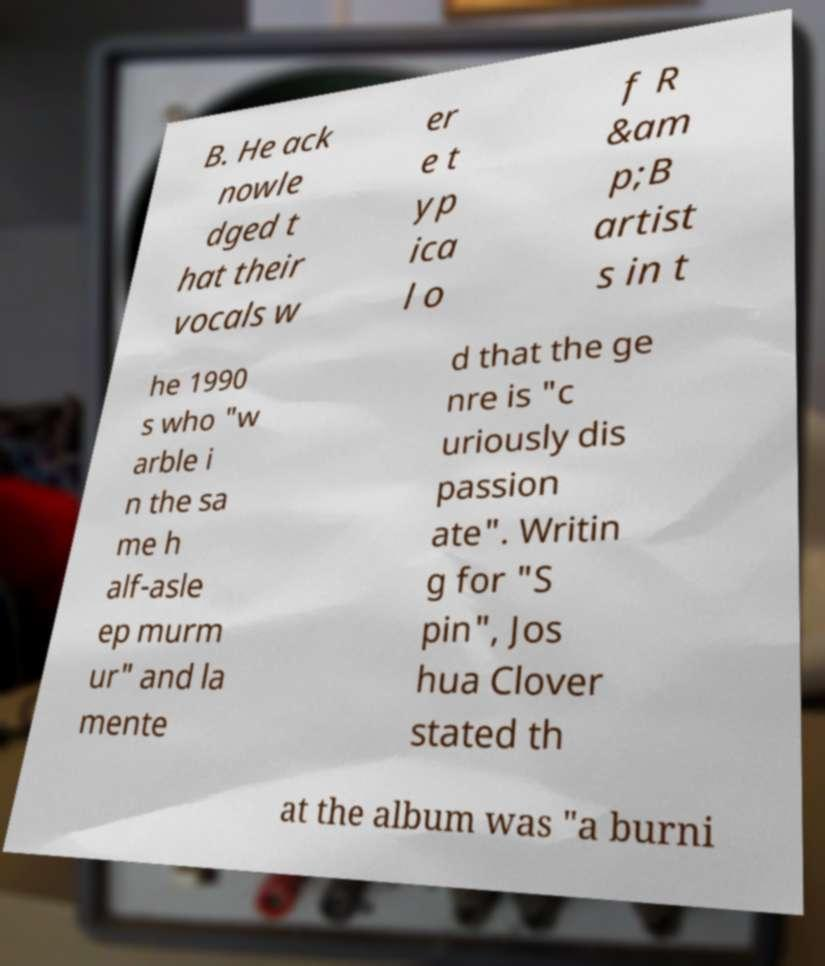Can you accurately transcribe the text from the provided image for me? B. He ack nowle dged t hat their vocals w er e t yp ica l o f R &am p;B artist s in t he 1990 s who "w arble i n the sa me h alf-asle ep murm ur" and la mente d that the ge nre is "c uriously dis passion ate". Writin g for "S pin", Jos hua Clover stated th at the album was "a burni 